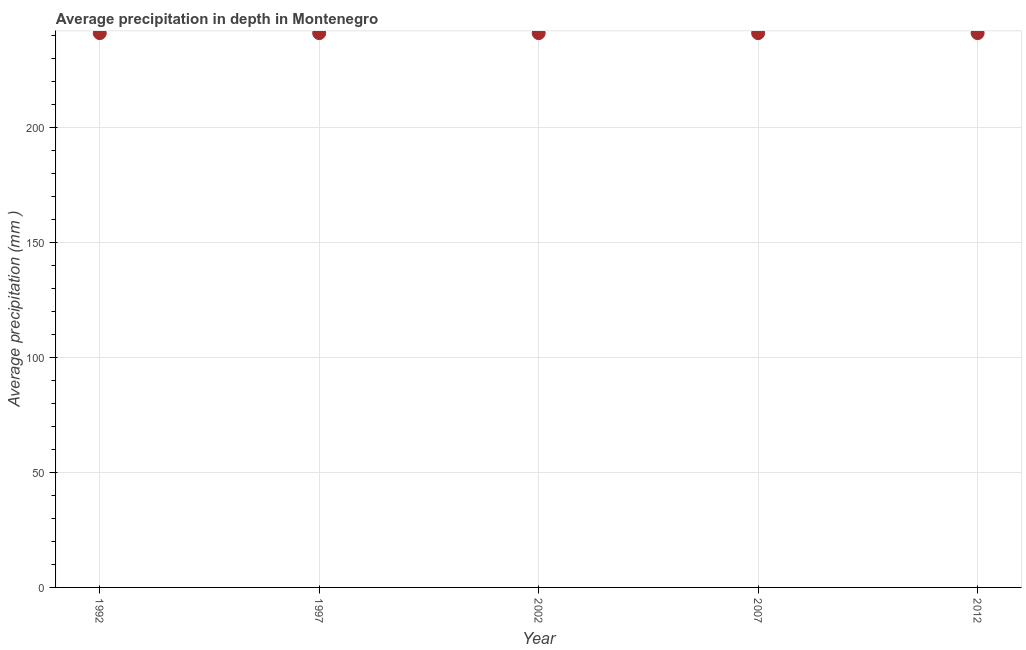What is the average precipitation in depth in 2012?
Your answer should be compact. 241. Across all years, what is the maximum average precipitation in depth?
Your response must be concise. 241. Across all years, what is the minimum average precipitation in depth?
Provide a short and direct response. 241. What is the sum of the average precipitation in depth?
Ensure brevity in your answer.  1205. What is the average average precipitation in depth per year?
Provide a short and direct response. 241. What is the median average precipitation in depth?
Offer a terse response. 241. In how many years, is the average precipitation in depth greater than 190 mm?
Provide a short and direct response. 5. Do a majority of the years between 2012 and 1997 (inclusive) have average precipitation in depth greater than 160 mm?
Your response must be concise. Yes. Is the average precipitation in depth in 1992 less than that in 2012?
Ensure brevity in your answer.  No. Does the average precipitation in depth monotonically increase over the years?
Make the answer very short. No. How many years are there in the graph?
Give a very brief answer. 5. What is the difference between two consecutive major ticks on the Y-axis?
Offer a very short reply. 50. Are the values on the major ticks of Y-axis written in scientific E-notation?
Make the answer very short. No. Does the graph contain any zero values?
Your answer should be compact. No. What is the title of the graph?
Give a very brief answer. Average precipitation in depth in Montenegro. What is the label or title of the X-axis?
Offer a very short reply. Year. What is the label or title of the Y-axis?
Your answer should be compact. Average precipitation (mm ). What is the Average precipitation (mm ) in 1992?
Provide a succinct answer. 241. What is the Average precipitation (mm ) in 1997?
Make the answer very short. 241. What is the Average precipitation (mm ) in 2002?
Offer a very short reply. 241. What is the Average precipitation (mm ) in 2007?
Your answer should be compact. 241. What is the Average precipitation (mm ) in 2012?
Provide a succinct answer. 241. What is the difference between the Average precipitation (mm ) in 1992 and 2007?
Provide a short and direct response. 0. What is the ratio of the Average precipitation (mm ) in 1992 to that in 2007?
Keep it short and to the point. 1. What is the ratio of the Average precipitation (mm ) in 1992 to that in 2012?
Provide a succinct answer. 1. What is the ratio of the Average precipitation (mm ) in 1997 to that in 2012?
Keep it short and to the point. 1. What is the ratio of the Average precipitation (mm ) in 2002 to that in 2007?
Your response must be concise. 1. What is the ratio of the Average precipitation (mm ) in 2007 to that in 2012?
Ensure brevity in your answer.  1. 